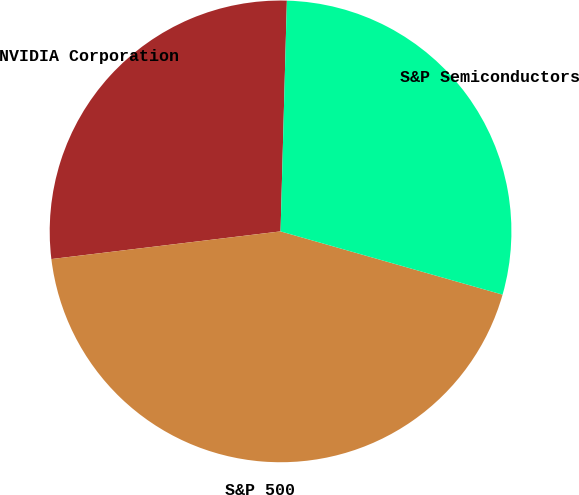Convert chart to OTSL. <chart><loc_0><loc_0><loc_500><loc_500><pie_chart><fcel>NVIDIA Corporation<fcel>S&P 500<fcel>S&P Semiconductors<nl><fcel>27.35%<fcel>43.67%<fcel>28.98%<nl></chart> 